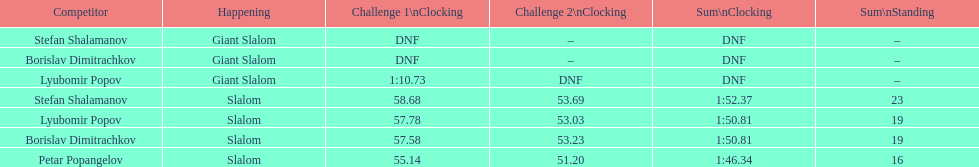Which athlete finished the first race but did not finish the second race? Lyubomir Popov. 